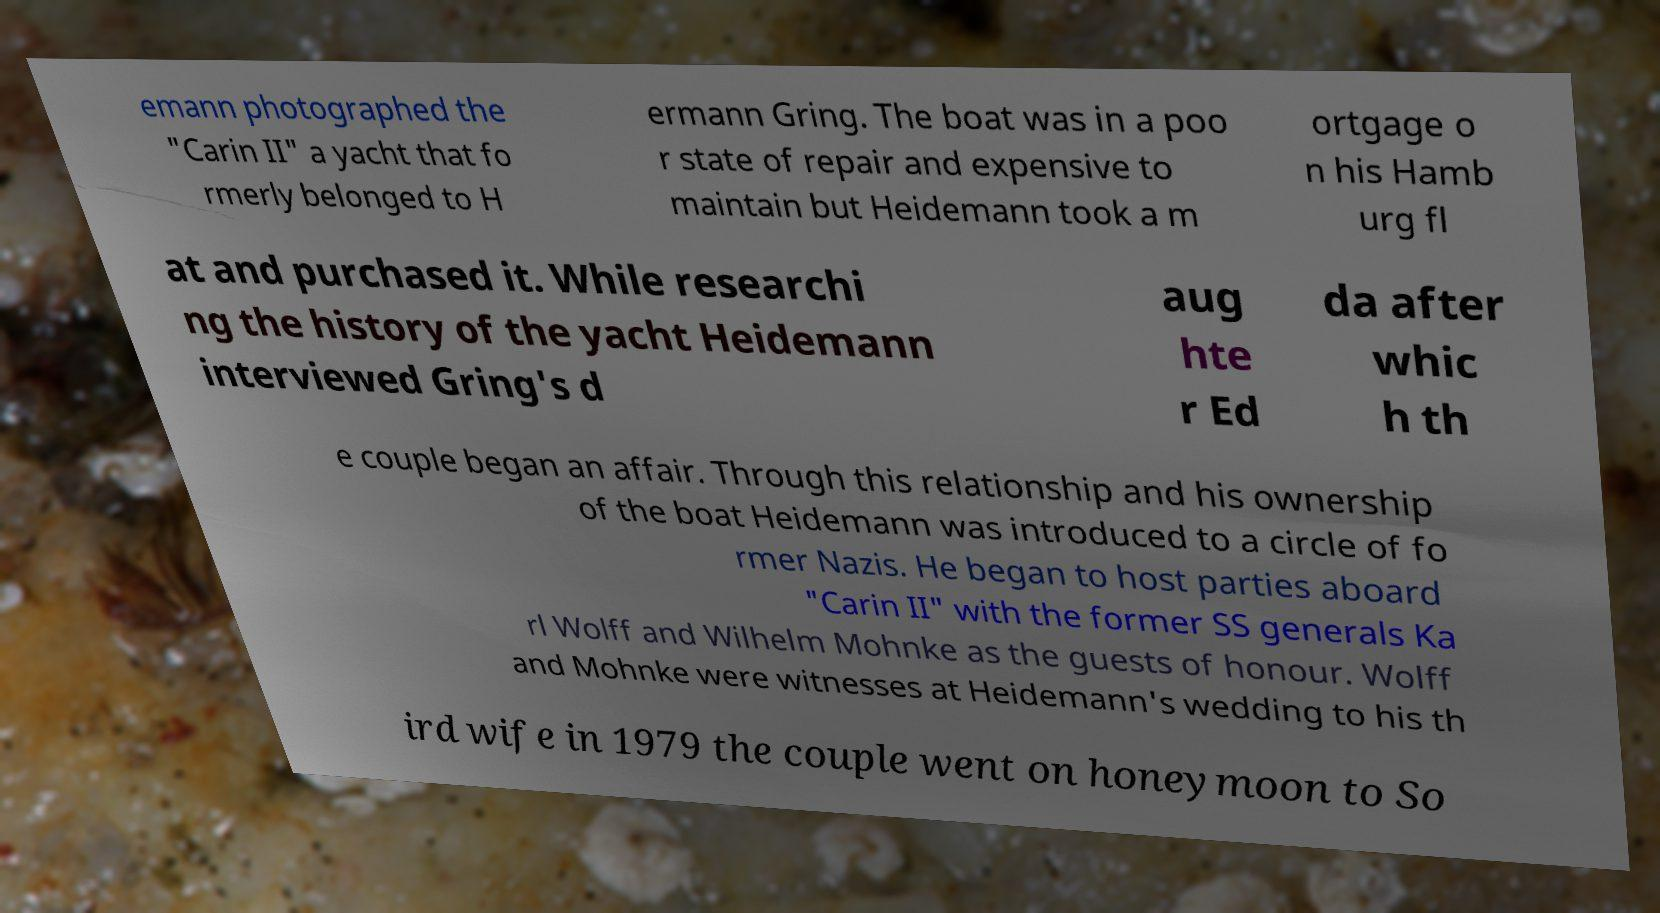Could you extract and type out the text from this image? emann photographed the "Carin II" a yacht that fo rmerly belonged to H ermann Gring. The boat was in a poo r state of repair and expensive to maintain but Heidemann took a m ortgage o n his Hamb urg fl at and purchased it. While researchi ng the history of the yacht Heidemann interviewed Gring's d aug hte r Ed da after whic h th e couple began an affair. Through this relationship and his ownership of the boat Heidemann was introduced to a circle of fo rmer Nazis. He began to host parties aboard "Carin II" with the former SS generals Ka rl Wolff and Wilhelm Mohnke as the guests of honour. Wolff and Mohnke were witnesses at Heidemann's wedding to his th ird wife in 1979 the couple went on honeymoon to So 